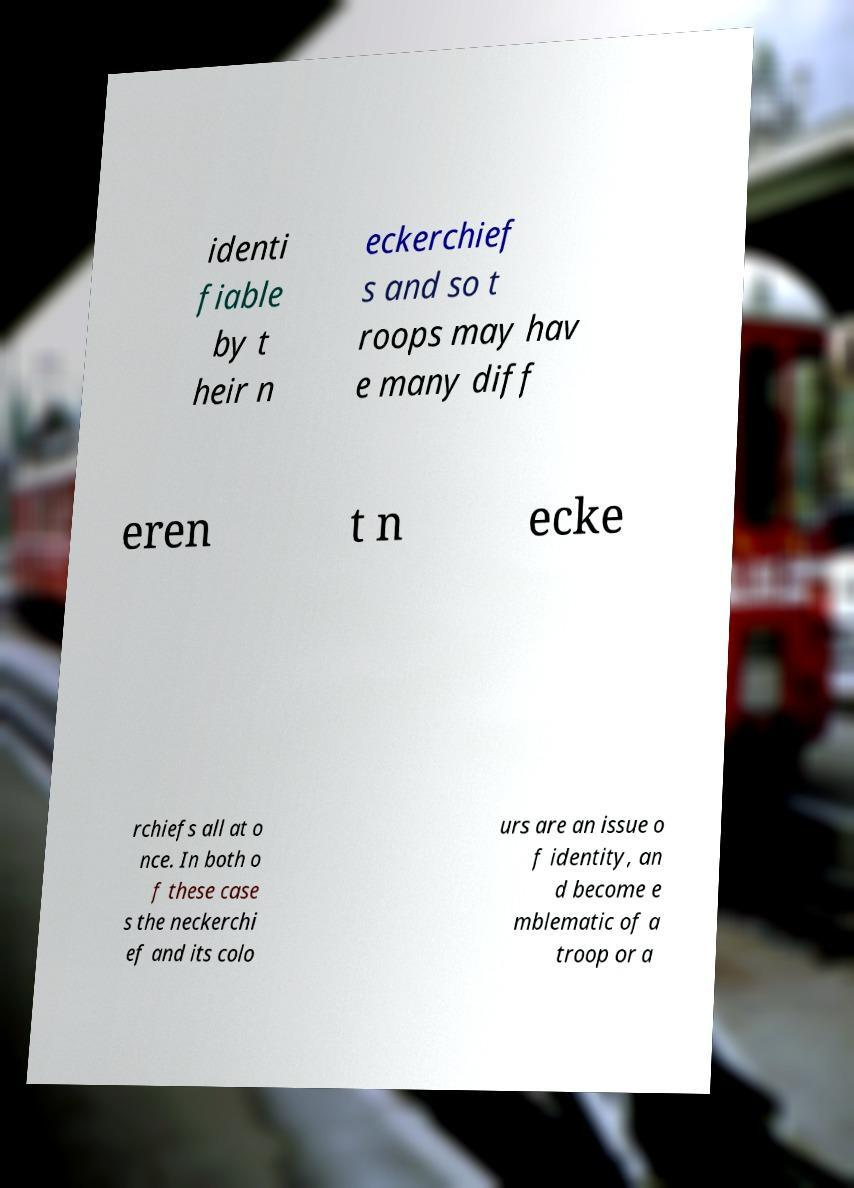For documentation purposes, I need the text within this image transcribed. Could you provide that? identi fiable by t heir n eckerchief s and so t roops may hav e many diff eren t n ecke rchiefs all at o nce. In both o f these case s the neckerchi ef and its colo urs are an issue o f identity, an d become e mblematic of a troop or a 